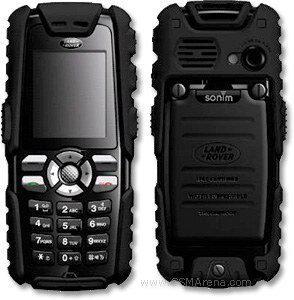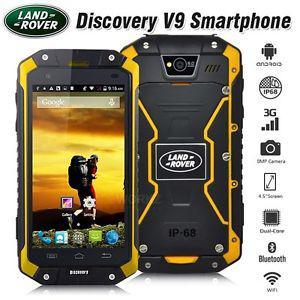The first image is the image on the left, the second image is the image on the right. Analyze the images presented: Is the assertion "Both of the images are showing two different views of the same cell phone." valid? Answer yes or no. Yes. The first image is the image on the left, the second image is the image on the right. Examine the images to the left and right. Is the description "The back of a phone is visible." accurate? Answer yes or no. Yes. 